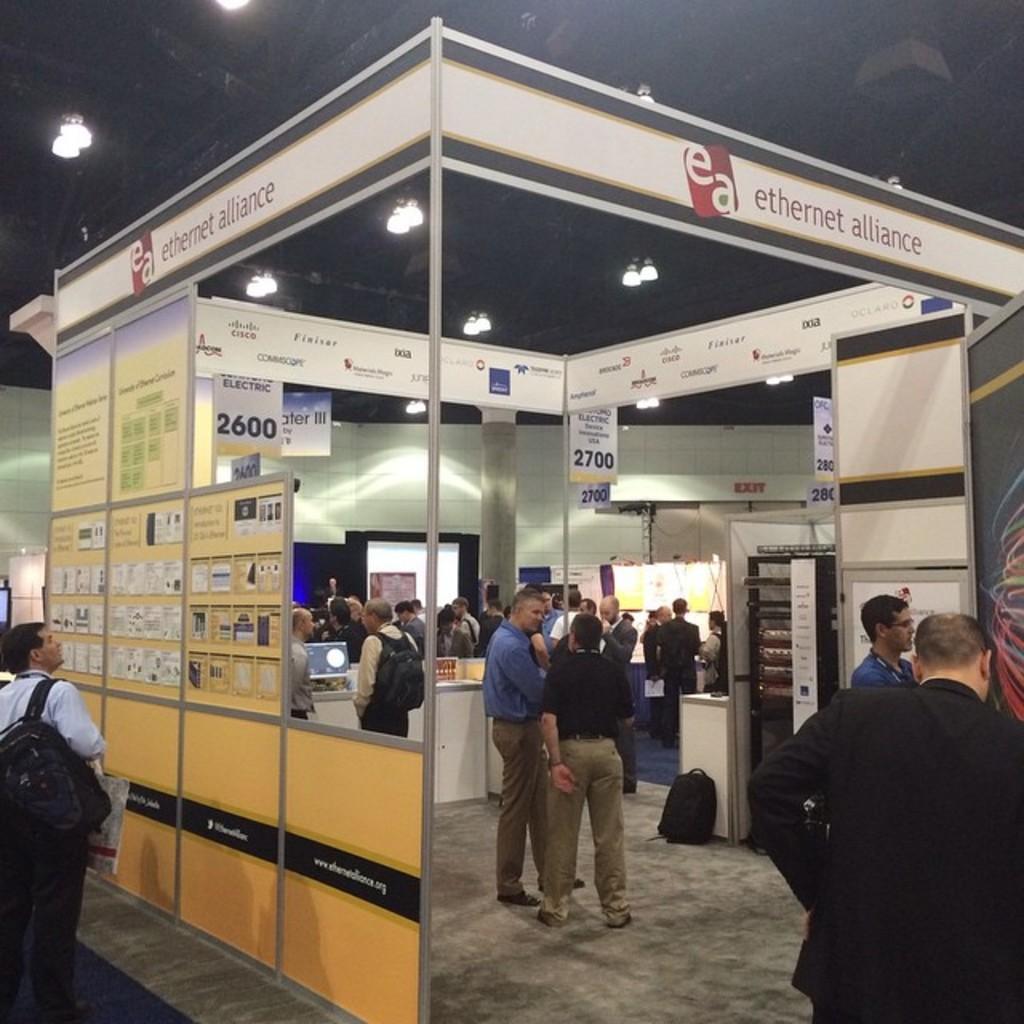How would you summarize this image in a sentence or two? In the picture there is a stall and there are many people inside that stall, there are different banners and counters inside the stall and in the background it is an exit board. 